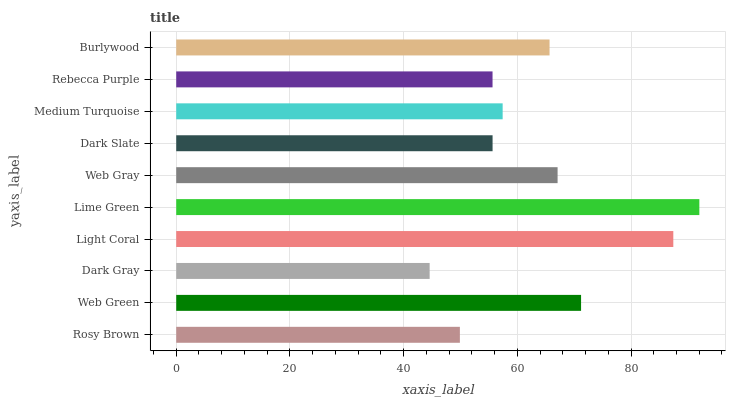Is Dark Gray the minimum?
Answer yes or no. Yes. Is Lime Green the maximum?
Answer yes or no. Yes. Is Web Green the minimum?
Answer yes or no. No. Is Web Green the maximum?
Answer yes or no. No. Is Web Green greater than Rosy Brown?
Answer yes or no. Yes. Is Rosy Brown less than Web Green?
Answer yes or no. Yes. Is Rosy Brown greater than Web Green?
Answer yes or no. No. Is Web Green less than Rosy Brown?
Answer yes or no. No. Is Burlywood the high median?
Answer yes or no. Yes. Is Medium Turquoise the low median?
Answer yes or no. Yes. Is Dark Gray the high median?
Answer yes or no. No. Is Burlywood the low median?
Answer yes or no. No. 